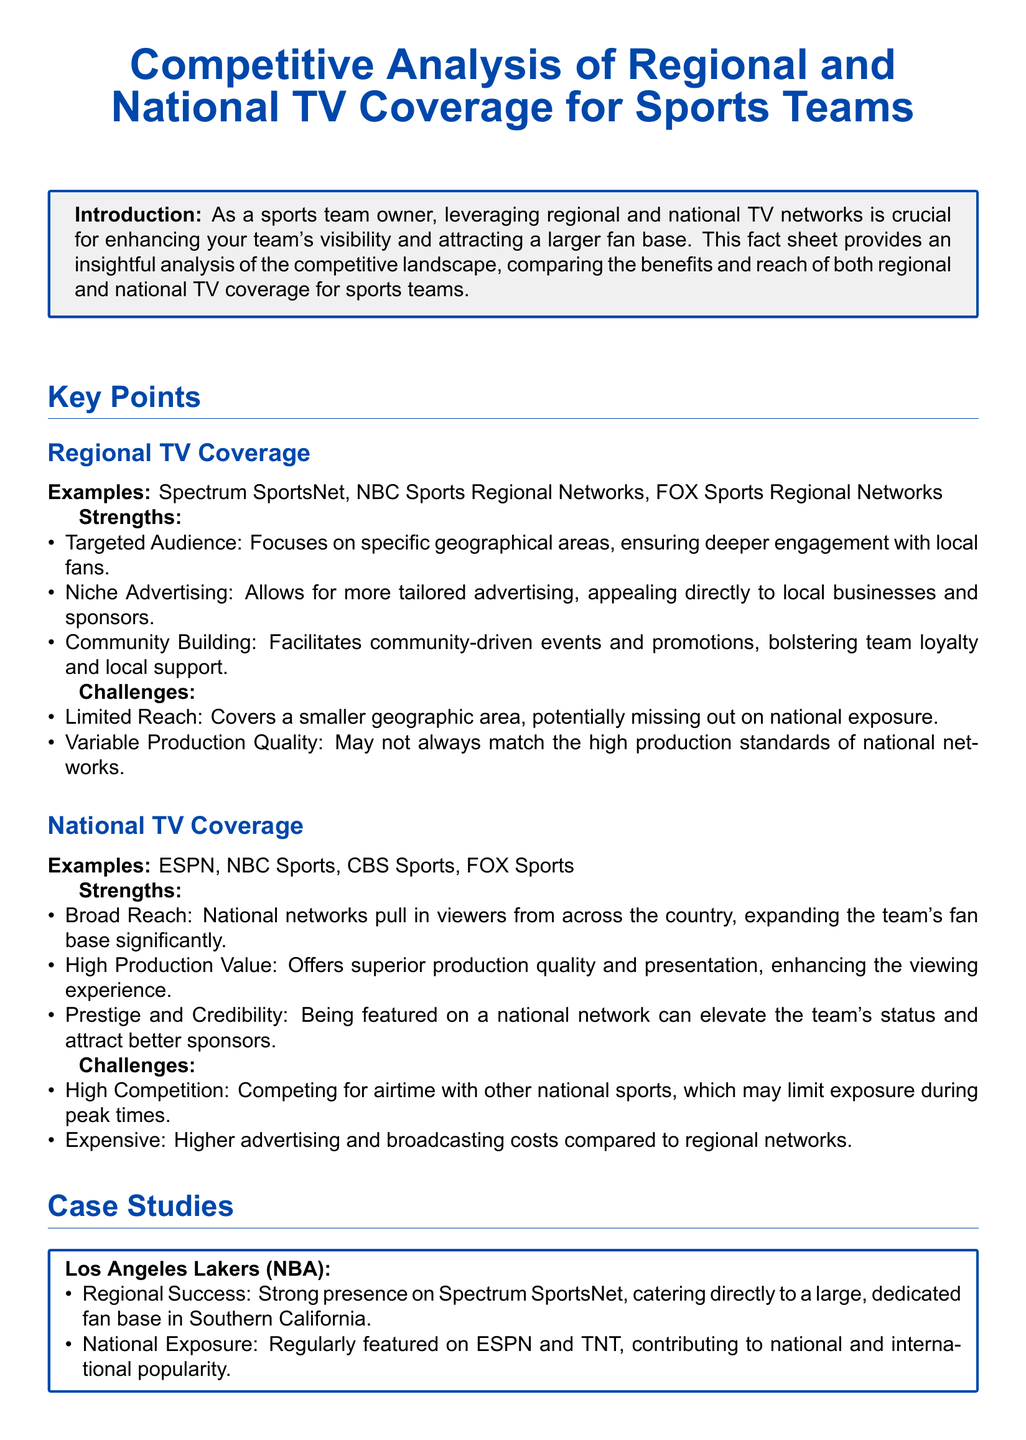What are examples of regional TV coverage? The document lists specific regional networks such as Spectrum SportsNet, NBC Sports Regional Networks, and FOX Sports Regional Networks.
Answer: Spectrum SportsNet, NBC Sports Regional Networks, FOX Sports Regional Networks What is a strength of national TV coverage? The document states that national networks have a broad reach, significantly expanding a team's fan base.
Answer: Broad Reach What is a challenge faced by regional TV coverage? The document mentions that a challenge includes limited reach, which can result in missing out on national exposure.
Answer: Limited Reach Which sports team had regular features on ESPN and TNT? The case study of the Los Angeles Lakers highlights that they are regularly featured on ESPN and TNT.
Answer: Los Angeles Lakers What is a community engagement strategy for the Green Bay Packers? The document notes that they have extensive local coverage through regional networks like Fox Sports Wisconsin, supporting their community image.
Answer: Extensive local coverage What is highlighted as a strength of regional TV coverage? The document lists targeted audience engagement as a strength of regional TV coverage.
Answer: Targeted Audience What conclusion does the document provide? The conclusion emphasizes the importance of balancing both regional and national TV coverage for enhancing visibility and engagement.
Answer: Balancing both regional and national TV coverage What is one of the challenges of national TV coverage? High competition for airtime with other national sports is identified as a challenge in the document.
Answer: High Competition What is the primary focus of this fact sheet? The fact sheet analyzes competitive TV coverage for sports teams, comparing regional and national networks.
Answer: Competitive TV coverage 